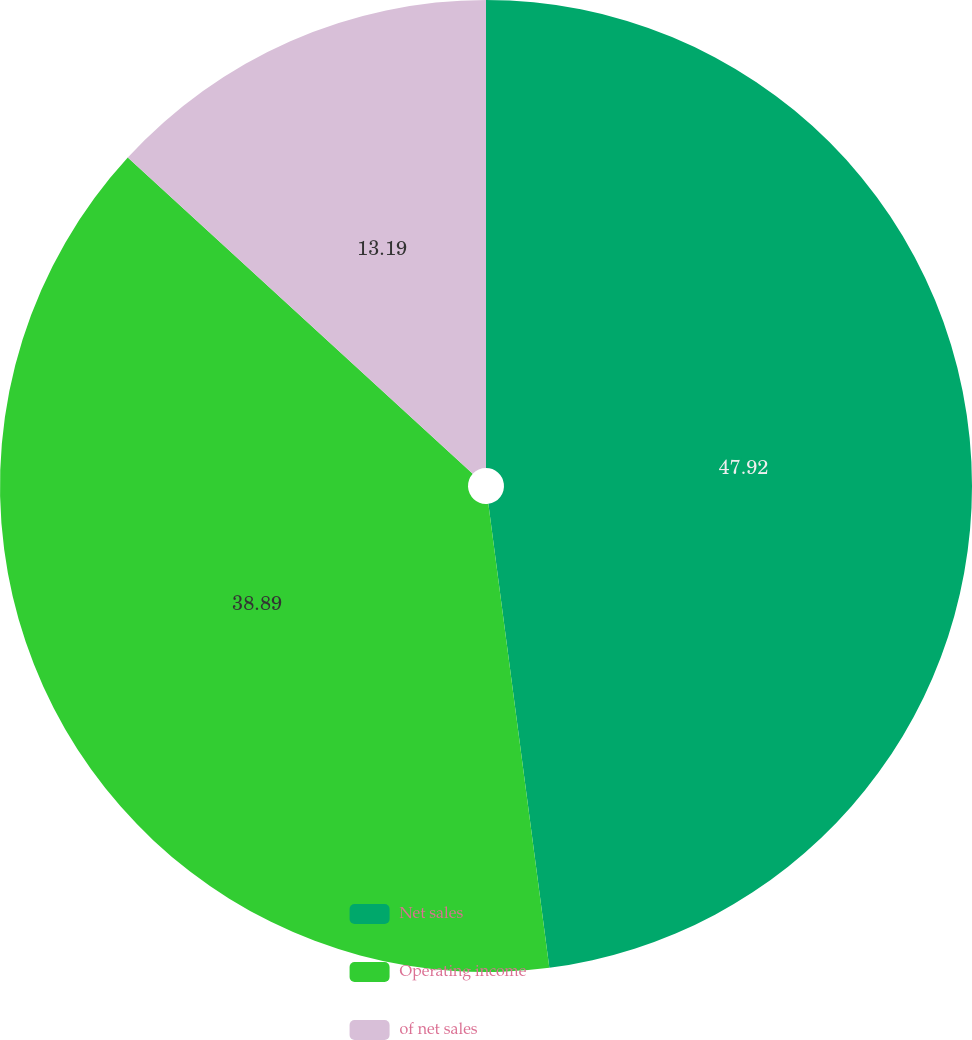Convert chart to OTSL. <chart><loc_0><loc_0><loc_500><loc_500><pie_chart><fcel>Net sales<fcel>Operating income<fcel>of net sales<nl><fcel>47.92%<fcel>38.89%<fcel>13.19%<nl></chart> 